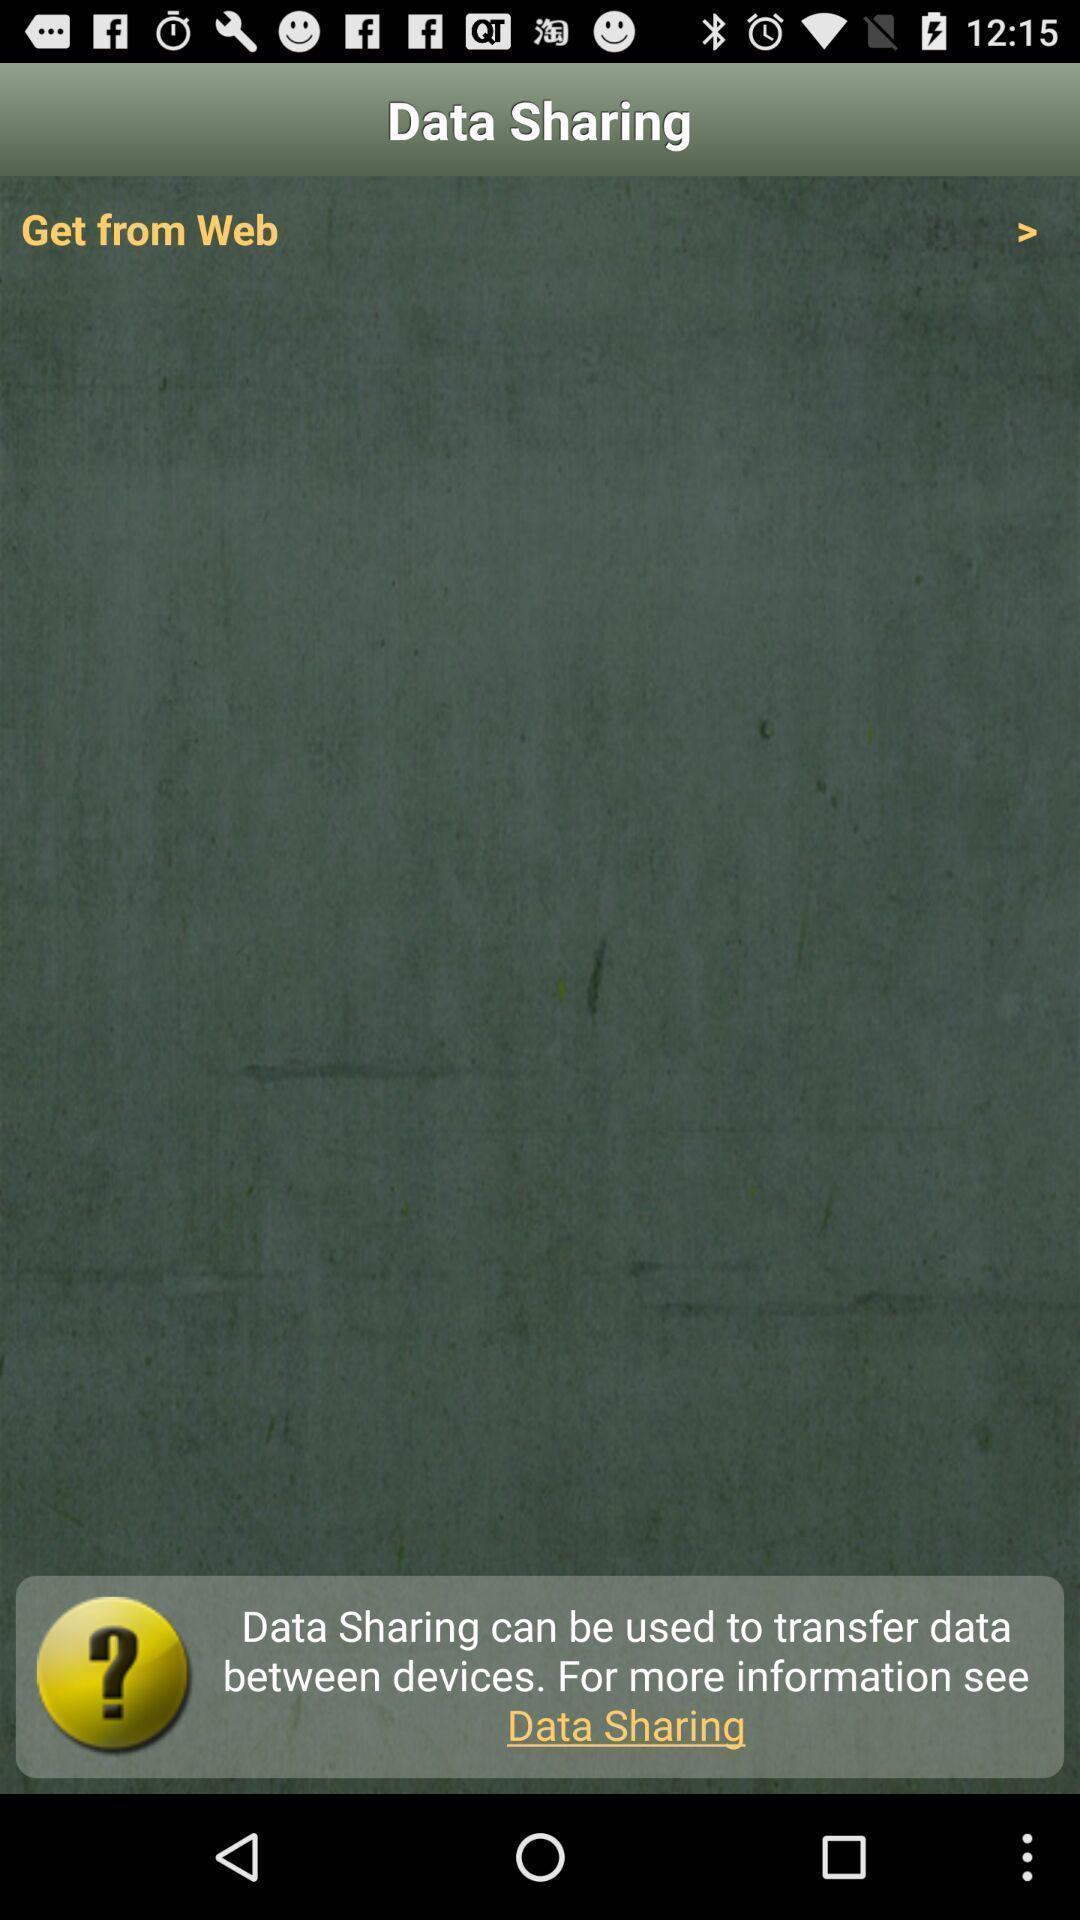Summarize the main components in this picture. Page showing the blank page in gaming app. 